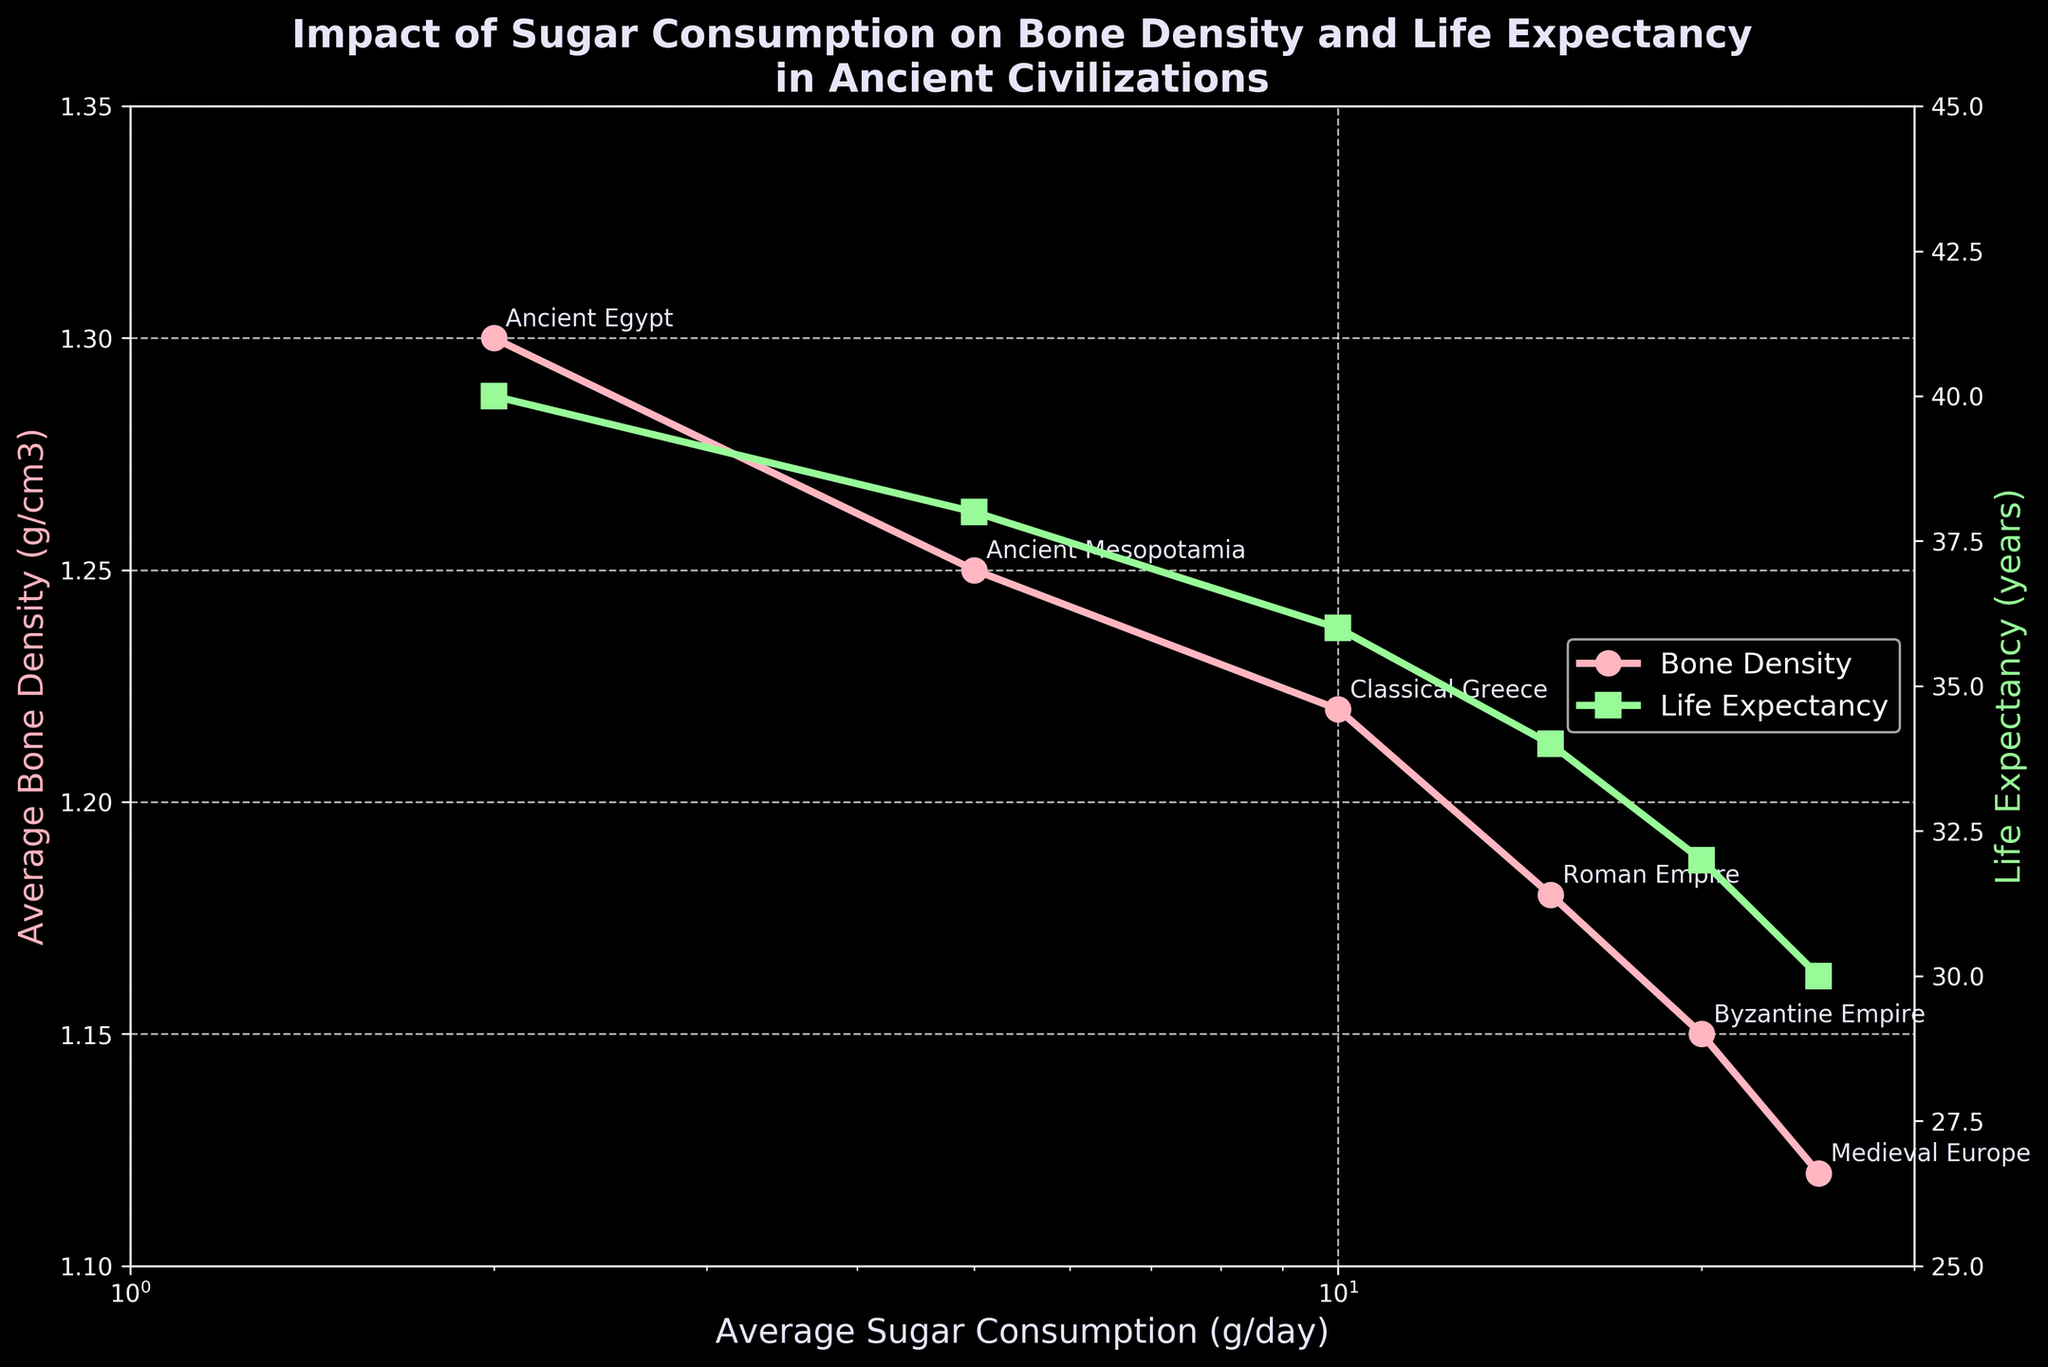What is the title of the figure? The title of the figure is typically found at the top of the plot, often centered and in a larger font size for visibility.
Answer: Impact of Sugar Consumption on Bone Density and Life Expectancy in Ancient Civilizations How is the life expectancy trend related to sugar consumption? By observing the plot lines related to life expectancy as sugar consumption increases on the log scale, we can see whether life expectancy rises, falls, or remains constant.
Answer: Life expectancy decreases as sugar consumption increases Which civilization had the highest average bone density? The average bone density values for each civilization are plotted on the left y-axis against the average sugar consumption. The civilization names are annotated near the data points for identification.
Answer: Ancient Egypt Between which periods did the most significant drop in average bone density occur? By comparing the values of average bone densities in adjacent periods on the plot, we can identify the largest drop. Calculate the differences between each consecutive period and find the largest.
Answer: Classical Greece to Roman Empire What are the average bone density and life expectancy for the period 1000 AD - 1500 AD? Locate the data point corresponding to 1000 AD - 1500 AD by its sugar consumption on the x-axis and read off the values from both y-axes.
Answer: 1.12 g/cm3 and 30 years For which period is the difference between bone density and life expectancy the smallest? Calculate the difference between the bone density (in appropriate units, considering they share no common units) and life expectancy for each period. Identify the smallest difference.
Answer: 1000 BC - 0 (Classical Greece) How does bone density change with increasing sugar consumption? Observe the trend line for bone density on the left y-axis as sugar consumption increases along the log scale x-axis. Note whether the bone density rises, falls, or remains constant as sugar consumption increases.
Answer: Bone density decreases as sugar consumption increases Which civilization shows the smallest decrease in life expectancy compared to the previous period? By comparing the life expectancy values for each consecutive civilization, determine the smallest decline. Subtract each period's life expectancy from the previous one to spot the smallest decrease.
Answer: Ancient Egypt to Ancient Mesopotamia Is there a direct correlation between sugar consumption and life expectancy based on the visual information? Review the plot and assess whether changes in one metric consistently result in changes in the other. A direct correlation would show consistent increase or decrease patterns together.
Answer: Yes, there's a negative correlation Comparing bone density and life expectancy, which metric shows more variability over time? Look at the range and fluctuations of each metric along their respective y-axes (left for bone density and right for life expectancy). Calculate or visually estimate the variability range for each.
Answer: Life expectancy 